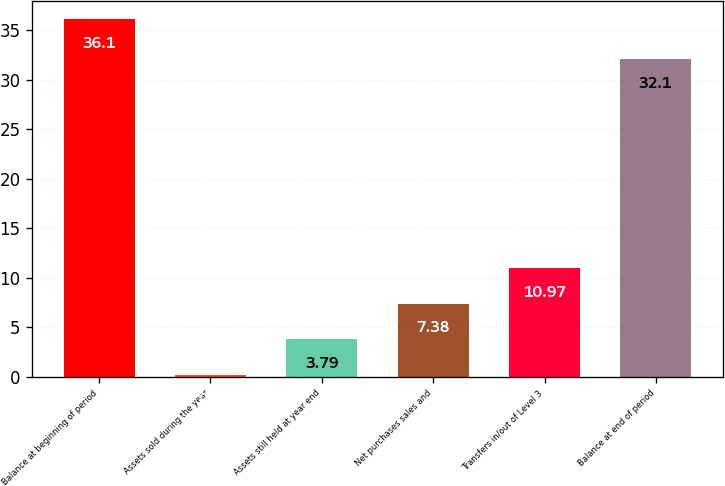Convert chart to OTSL. <chart><loc_0><loc_0><loc_500><loc_500><bar_chart><fcel>Balance at beginning of period<fcel>Assets sold during the year<fcel>Assets still held at year end<fcel>Net purchases sales and<fcel>Transfers in/out of Level 3<fcel>Balance at end of period<nl><fcel>36.1<fcel>0.2<fcel>3.79<fcel>7.38<fcel>10.97<fcel>32.1<nl></chart> 